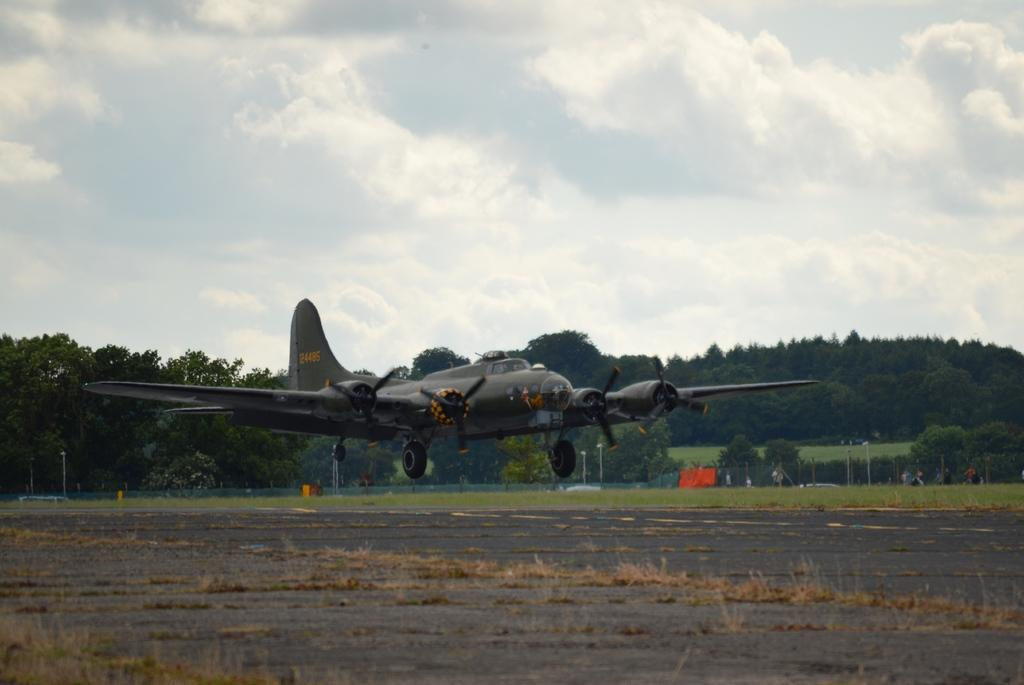What is the main subject of the image? The main subject of the image is an airplane. What type of natural environment is visible in the image? There are trees in the image, indicating a natural setting. What is visible at the top of the image? The sky is visible at the top of the image. What type of linen is draped over the airplane's wings in the image? There is no linen draped over the airplane's wings in the image. How does the airplane's pocket affect its flight in the image? Airplanes do not have pockets, so this question cannot be answered. 